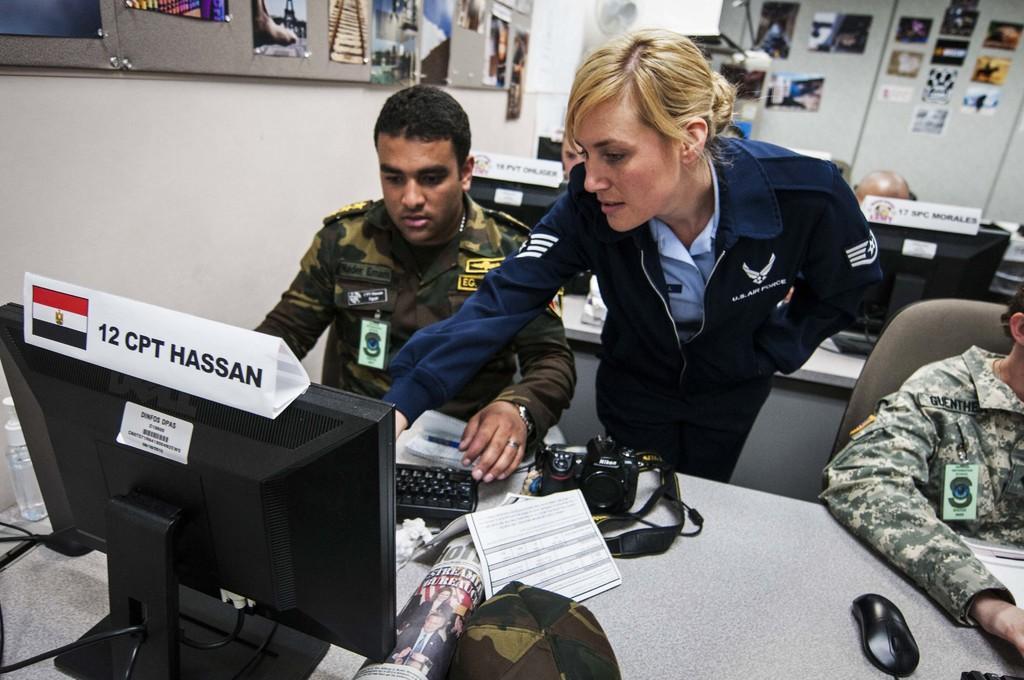Could you give a brief overview of what you see in this image? In this picture there are people and we can see monitors, name boards, key board, bottle, cap, mouse, papers and objects on table. In the background of the image we can see boards, object and photos on the wall. 